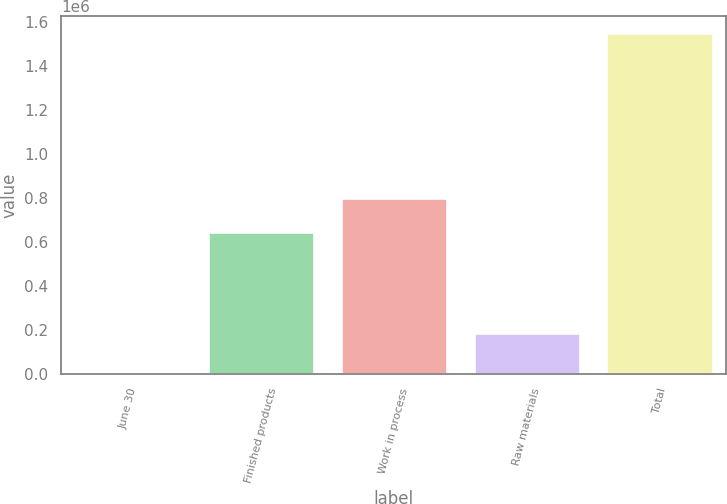Convert chart to OTSL. <chart><loc_0><loc_0><loc_500><loc_500><bar_chart><fcel>June 30<fcel>Finished products<fcel>Work in process<fcel>Raw materials<fcel>Total<nl><fcel>2017<fcel>642788<fcel>797536<fcel>183573<fcel>1.54949e+06<nl></chart> 